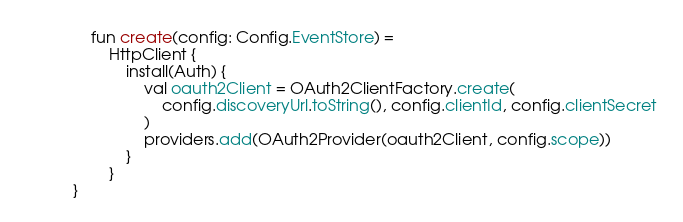<code> <loc_0><loc_0><loc_500><loc_500><_Kotlin_>    fun create(config: Config.EventStore) =
        HttpClient {
            install(Auth) {
                val oauth2Client = OAuth2ClientFactory.create(
                    config.discoveryUrl.toString(), config.clientId, config.clientSecret
                )
                providers.add(OAuth2Provider(oauth2Client, config.scope))
            }
        }
}
</code> 